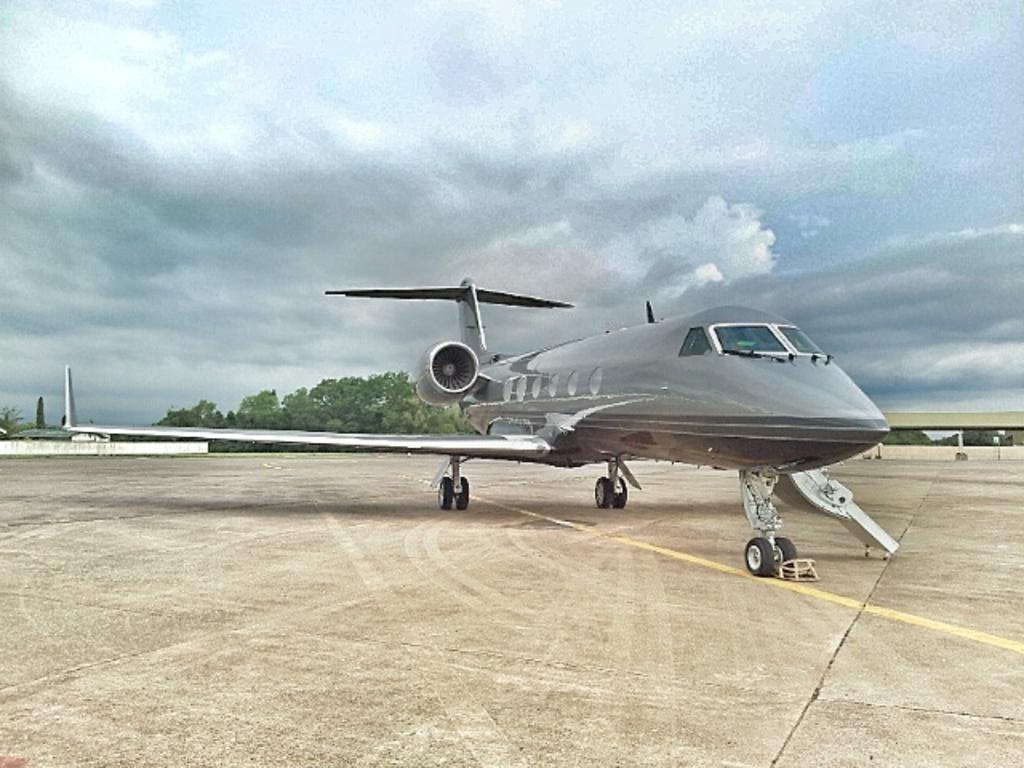Describe this image in one or two sentences. There is an airplane on the empty land,behind the plane there are lot of trees and in the background there is a sky. 